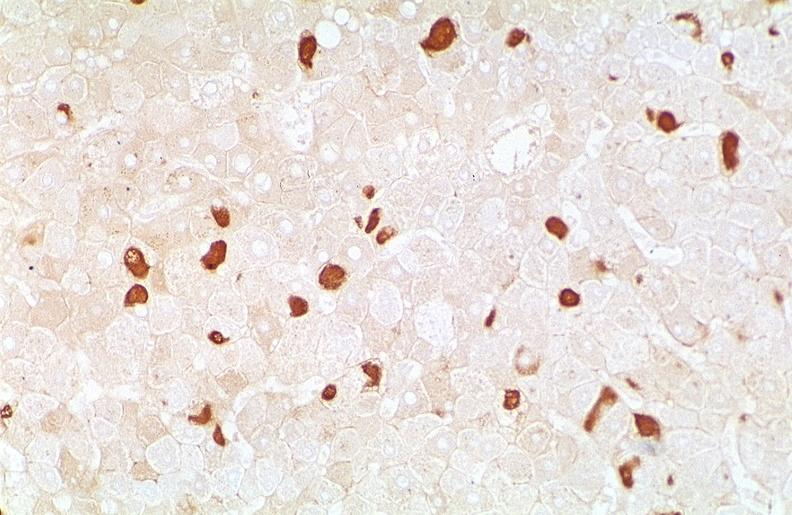s liver present?
Answer the question using a single word or phrase. Yes 